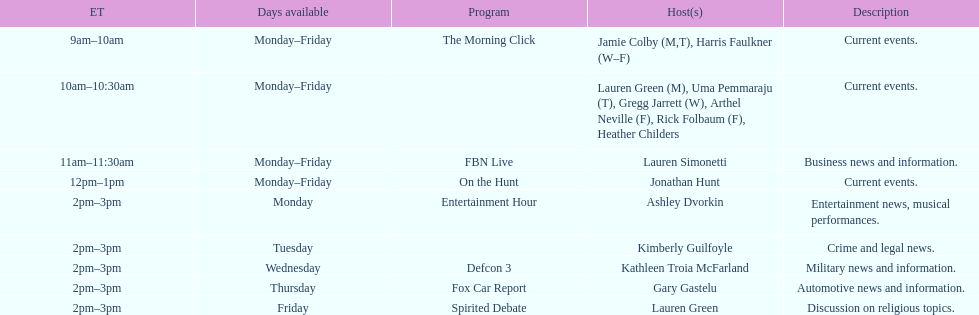What is the duration of on the hunt? 1 hour. 